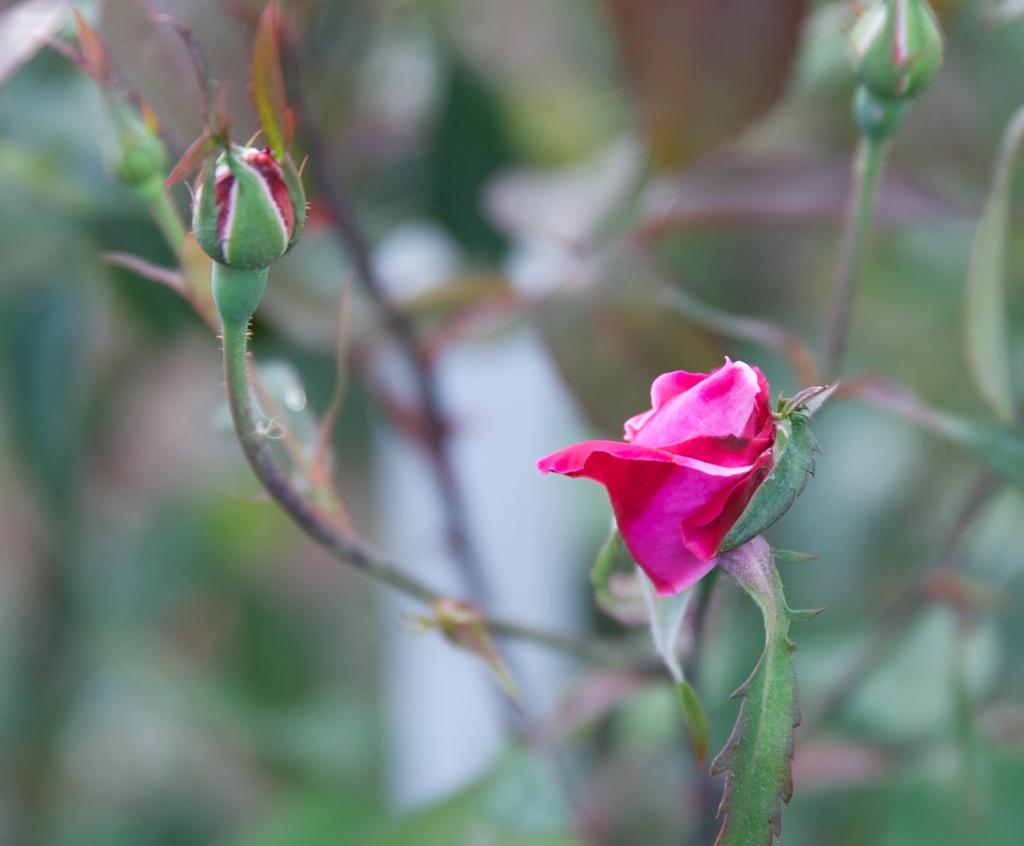What is the main subject of the image? There is a flower in the image. What stage of growth are some parts of the flower in? There are buds in the image. What type of vegetation can be seen in the background of the image? There are leaves visible in the background of the image. How would you describe the clarity of the image? The image is blurry. What type of coil can be seen in the image? There is no coil present in the image; it features a flower and buds. Can you tell me how many pets are visible in the image? There are no pets present in the image; it features a flower and buds. 